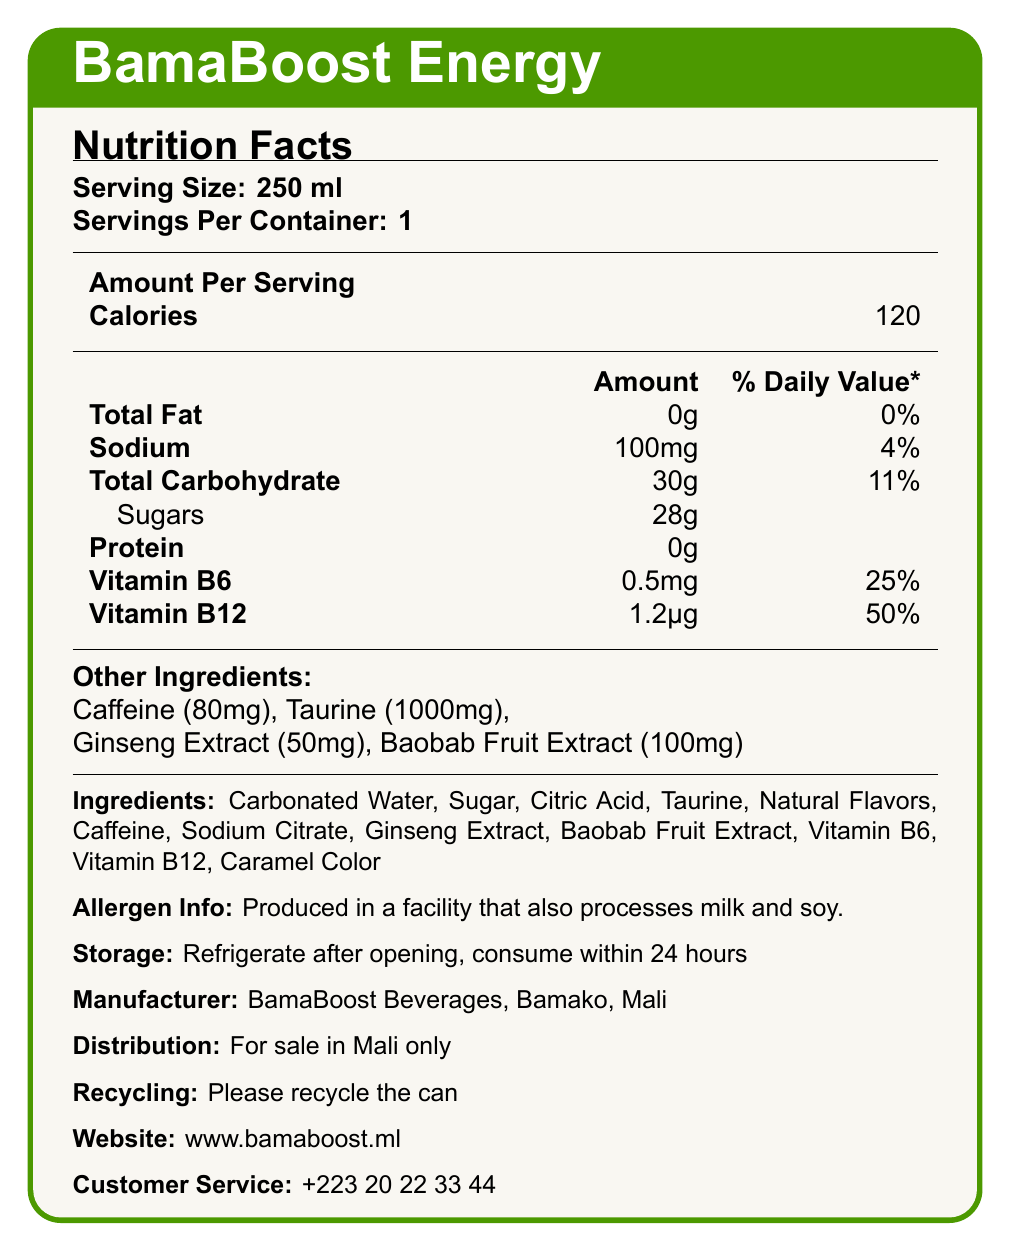what is the serving size of BamaBoost Energy? The serving size is stated under the "Nutrition Facts" section as "Serving Size: 250 ml".
Answer: 250 ml how many calories are in a single serving? The amount of calories per serving is listed as "Calories: 120" in the "Amount Per Serving" section.
Answer: 120 what percentage of the daily value of vitamin B12 does one serving provide? In the nutrition information, it says "Vitamin B12: 1.2µg (50%)", meaning one serving provides 50% of the daily value of Vitamin B12.
Answer: 50% how many grams of sugar are in a single serving? The nutrition label specifies under carbohydrates: "Sugars: 28g".
Answer: 28g does BamaBoost Energy contain any protein? The nutrition label lists protein as "0g", which means it contains no protein.
Answer: No which ingredient is present in the largest amount? The list of ingredients is usually presented in descending order by weight, and Carbonated Water is the first on the list.
Answer: Carbonated Water what is the recommended storage instruction for this drink? The storage instruction is provided at the bottom part of the label: "Refrigerate after opening, consume within 24 hours".
Answer: Refrigerate after opening, consume within 24 hours from where is BamaBoost Energy distributed? The label states under Distribution: "For sale in Mali only".
Answer: For sale in Mali only what is the contact information for customer service? The contact number for customer service is listed as "+223 20 22 33 44" at the bottom of the label.
Answer: +223 20 22 33 44 what should you do with the can after drinking? The label instructs to "Please recycle the can".
Answer: Please recycle the can what are the main ingredients in BamaBoost Energy? The main ingredients are listed towards the bottom of the label.
Answer: Carbonated Water, Sugar, Citric Acid, Taurine, Natural Flavors, Caffeine, Sodium Citrate, Ginseng Extract, Baobab Fruit Extract, Vitamin B6, Vitamin B12, Caramel Color what is the amount of caffeine in a single serving? The other ingredients section indicates: "Caffeine (80mg)".
Answer: 80mg what is the daily value percentage of total carbohydrates in one serving? A. 4% B. 11% C. 25% D. 50% The nutrition label shows "Total Carbohydrate: 30g (11%)", indicating 11% of the daily value.
Answer: B. 11% which of the following vitamins are present in BamaBoost Energy? A. Vitamin C B. Vitamin B6 C. Vitamin D D. Vitamin B12 The vitamins listed are Vitamin B6 (0.5mg, 25%) and Vitamin B12 (1.2µg, 50%).
Answer: B and D does this product contain any allergens? The label specifies: "Produced in a facility that also processes milk and soy."
Answer: Yes describe the main idea of this document. The label gives comprehensive information on the nutritional value and contents of BamaBoost Energy, focusing on its suitability for young professionals in Bamako.
Answer: The document is a detailed Nutrition Facts label for BamaBoost Energy, an energy drink produced in Bamako, Mali. It includes information on serving size, nutritional content, ingredients, storage instructions, manufacturing and distribution details, recycling information, and customer service contact. how much taurine is in one serving of BamaBoost Energy? The other ingredients section specifies: "Taurine (1000mg)".
Answer: 1000mg what is the source of flavor in BamaBoost Energy? Within the ingredients list, "Natural Flavors" is mentioned as the source of flavor.
Answer: Natural Flavors is this product suitable for individuals who are allergic to milk or soy? The allergen information states it is produced in a facility that processes milk and soy, implying potential contamination risk.
Answer: No where can more information about BamaBoost Energy be found online? The label provides the website "www.bamaboost.ml" for more information.
Answer: www.bamaboost.ml what is the sodium content of one serving? The nutrition label indicates for sodium: "100mg (4%)".
Answer: 100mg can this product be sold outside of Mali? The distribution section states: "For sale in Mali only".
Answer: No what is the percent daily value of total fat in one serving? The total fat is marked as "0g (0%)" in the nutrition section.
Answer: 0% how many servings are in one container of BamaBoost Energy? The serving information is given as "Servings Per Container: 1".
Answer: 1 what is the source of the caramel color in the drink? The document does not specify the source of the caramel color used in the drink.
Answer: I don't know what should be done if the drink is not finished in one go? A. Store in a cupboard B. Throw it away C. Refrigerate and consume within 24 hours The storage instructions say, "Refrigerate after opening, consume within 24 hours".
Answer: C. Refrigerate and consume within 24 hours 